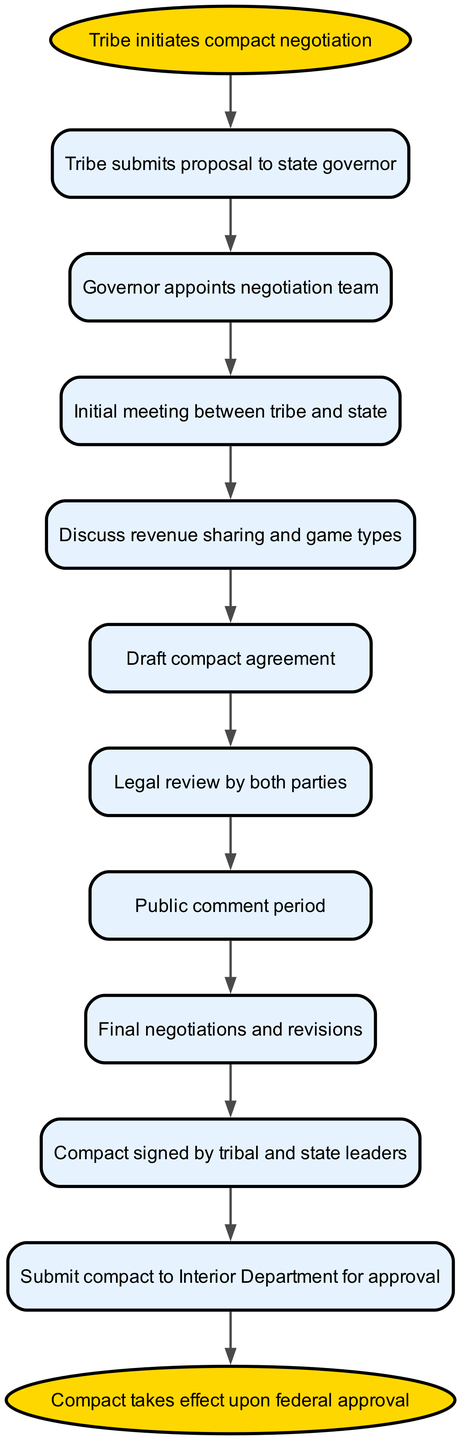What is the first step in the negotiation process? The first step according to the diagram is where the tribe initiates compact negotiation, represented as the starting point.
Answer: Tribe initiates compact negotiation How many steps are in the negotiation process? By counting the number of nodes excluding the start and end nodes, there are 10 steps in total, showing the process from initiation to federal approval.
Answer: 10 What is discussed in step four of the process? In step four, the diagram indicates that revenue sharing and game types are discussed, which are crucial aspects of the compact agreement.
Answer: Revenue sharing and game types What follows the legal review by both parties? After the legal review by both parties, there is a public comment period indicated as step seven in the diagram, following the legal review step six.
Answer: Public comment period Which step comes immediately before the compact is signed? The step that comes immediately before the compact is signed is the final negotiations and revisions depicted as step eight, which takes place after the compact draft is completed.
Answer: Final negotiations and revisions Who is responsible for signing the compact according to the diagram? The compact is signed by tribal and state leaders, which is specified in step nine of the process, indicating key accountability for the agreement.
Answer: Tribal and state leaders What is the last action required in the process? The last action required after the compact is signed is to submit the compact to the Interior Department for approval, which is step ten in the flowchart.
Answer: Submit compact to Interior Department for approval What triggers the compact to take effect? The compact takes effect upon federal approval, which is noted at the end of the diagram as the final outcome of the process.
Answer: Federal approval 